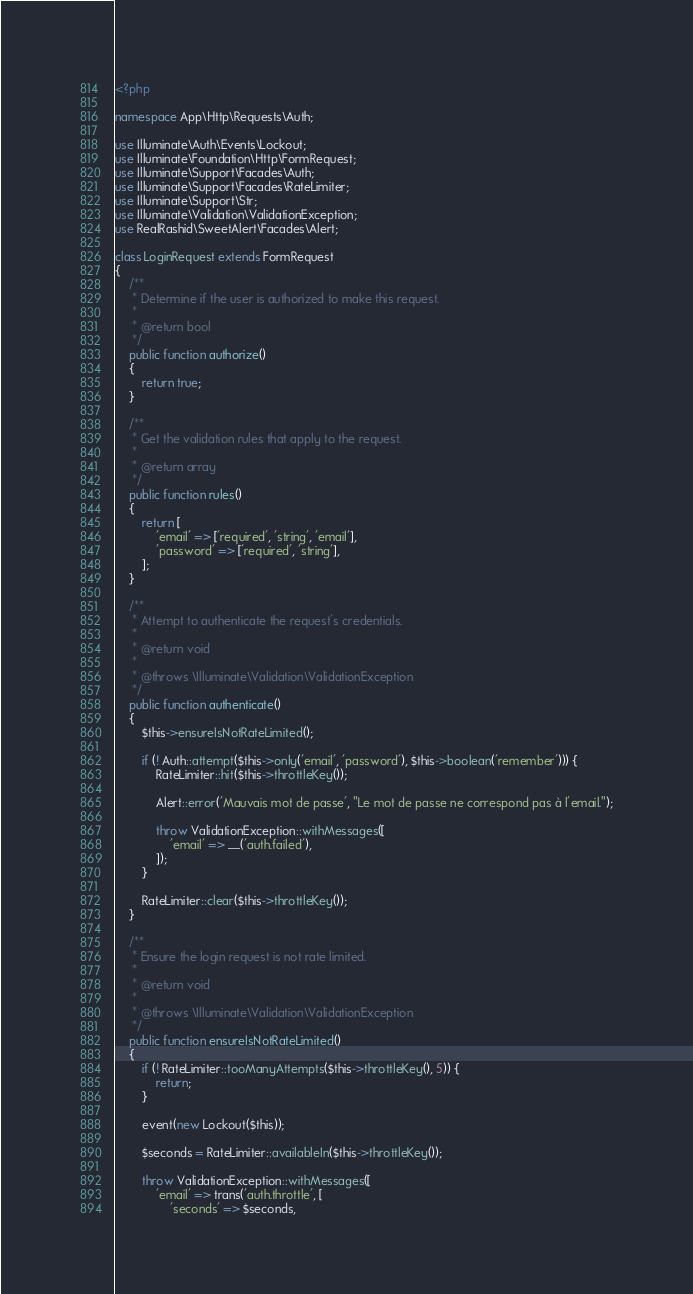Convert code to text. <code><loc_0><loc_0><loc_500><loc_500><_PHP_><?php

namespace App\Http\Requests\Auth;

use Illuminate\Auth\Events\Lockout;
use Illuminate\Foundation\Http\FormRequest;
use Illuminate\Support\Facades\Auth;
use Illuminate\Support\Facades\RateLimiter;
use Illuminate\Support\Str;
use Illuminate\Validation\ValidationException;
use RealRashid\SweetAlert\Facades\Alert;

class LoginRequest extends FormRequest
{
    /**
     * Determine if the user is authorized to make this request.
     *
     * @return bool
     */
    public function authorize()
    {
        return true;
    }

    /**
     * Get the validation rules that apply to the request.
     *
     * @return array
     */
    public function rules()
    {
        return [
            'email' => ['required', 'string', 'email'],
            'password' => ['required', 'string'],
        ];
    }

    /**
     * Attempt to authenticate the request's credentials.
     *
     * @return void
     *
     * @throws \Illuminate\Validation\ValidationException
     */
    public function authenticate()
    {
        $this->ensureIsNotRateLimited();

        if (! Auth::attempt($this->only('email', 'password'), $this->boolean('remember'))) {
            RateLimiter::hit($this->throttleKey());

            Alert::error('Mauvais mot de passe', "Le mot de passe ne correspond pas à l'email.");

            throw ValidationException::withMessages([
                'email' => __('auth.failed'),
            ]);
        }

        RateLimiter::clear($this->throttleKey());
    }

    /**
     * Ensure the login request is not rate limited.
     *
     * @return void
     *
     * @throws \Illuminate\Validation\ValidationException
     */
    public function ensureIsNotRateLimited()
    {
        if (! RateLimiter::tooManyAttempts($this->throttleKey(), 5)) {
            return;
        }

        event(new Lockout($this));

        $seconds = RateLimiter::availableIn($this->throttleKey());

        throw ValidationException::withMessages([
            'email' => trans('auth.throttle', [
                'seconds' => $seconds,</code> 